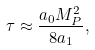<formula> <loc_0><loc_0><loc_500><loc_500>\tau \approx \frac { a _ { 0 } M _ { P } ^ { 2 } } { 8 a _ { 1 } } ,</formula> 